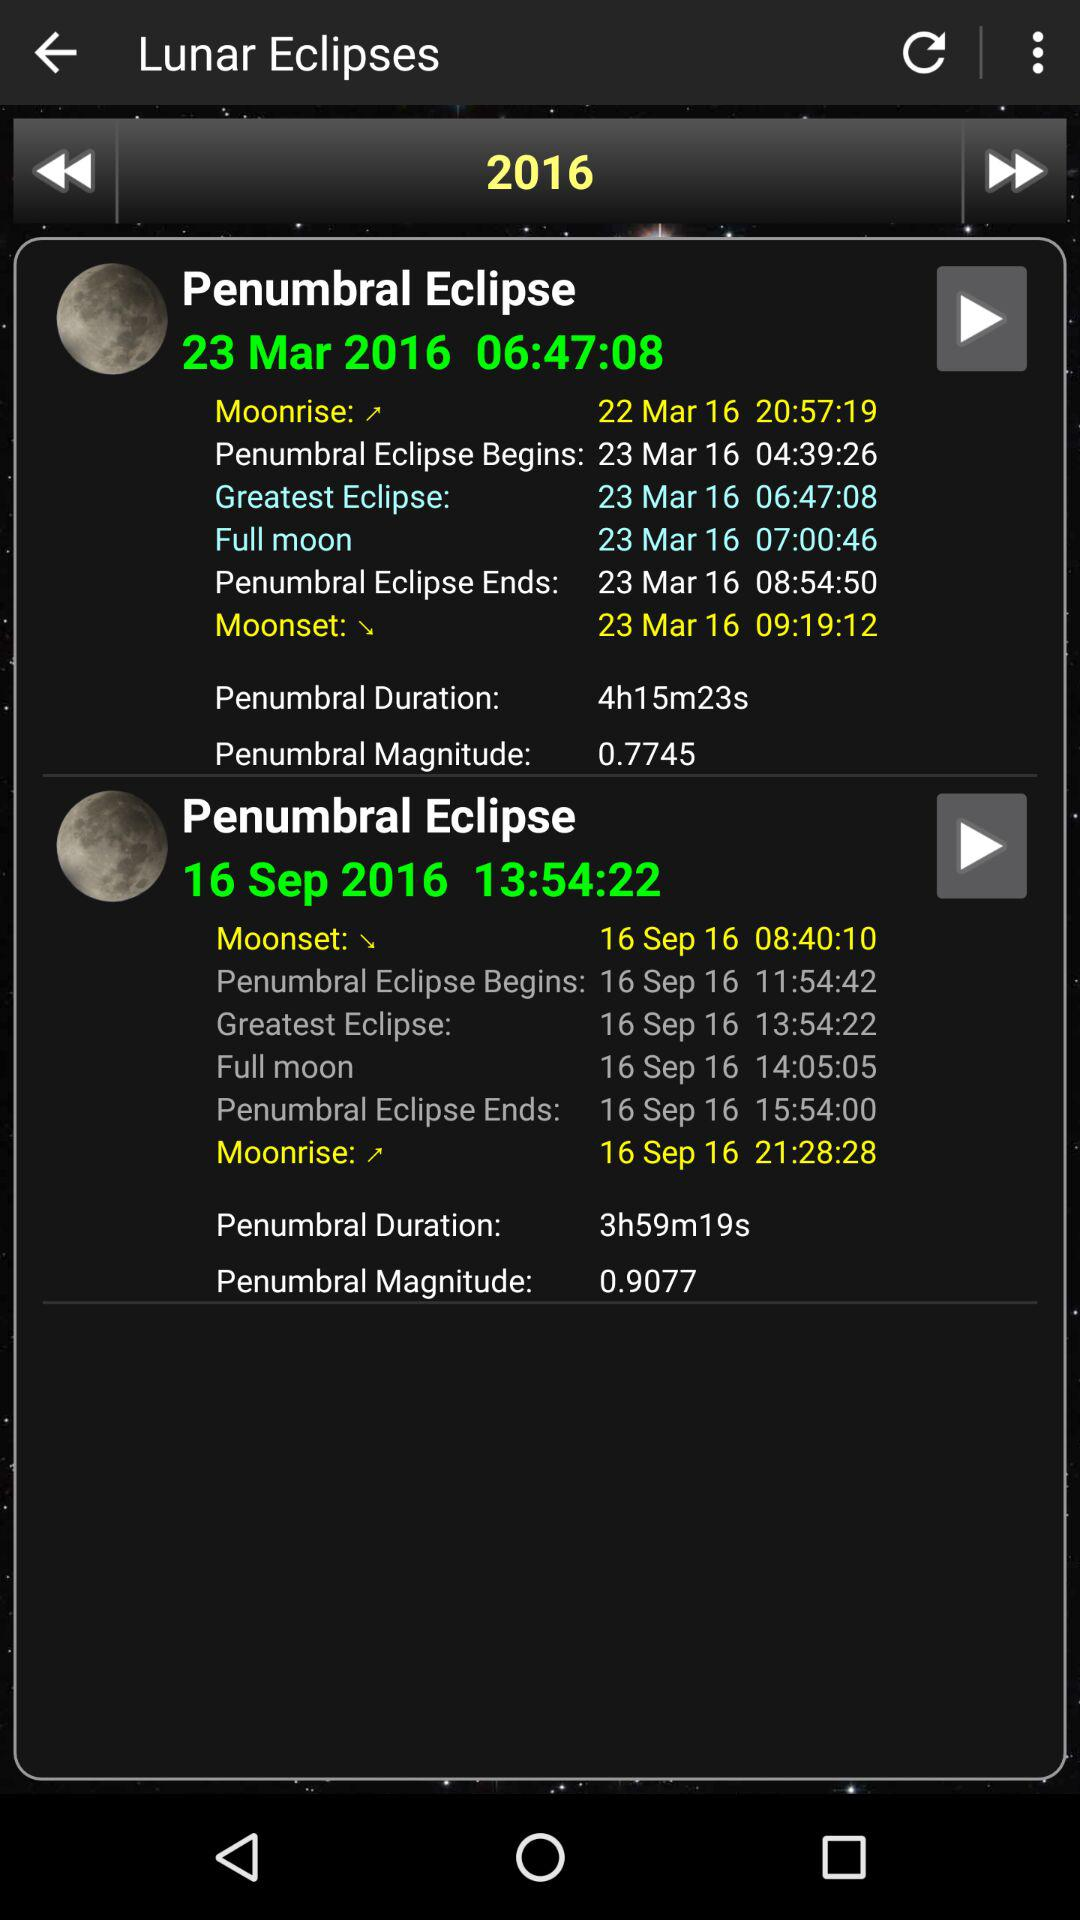What is the penumbral duration of September 16th? The penumbral duration is 3 hours 59 minutes and 19 seconds. 